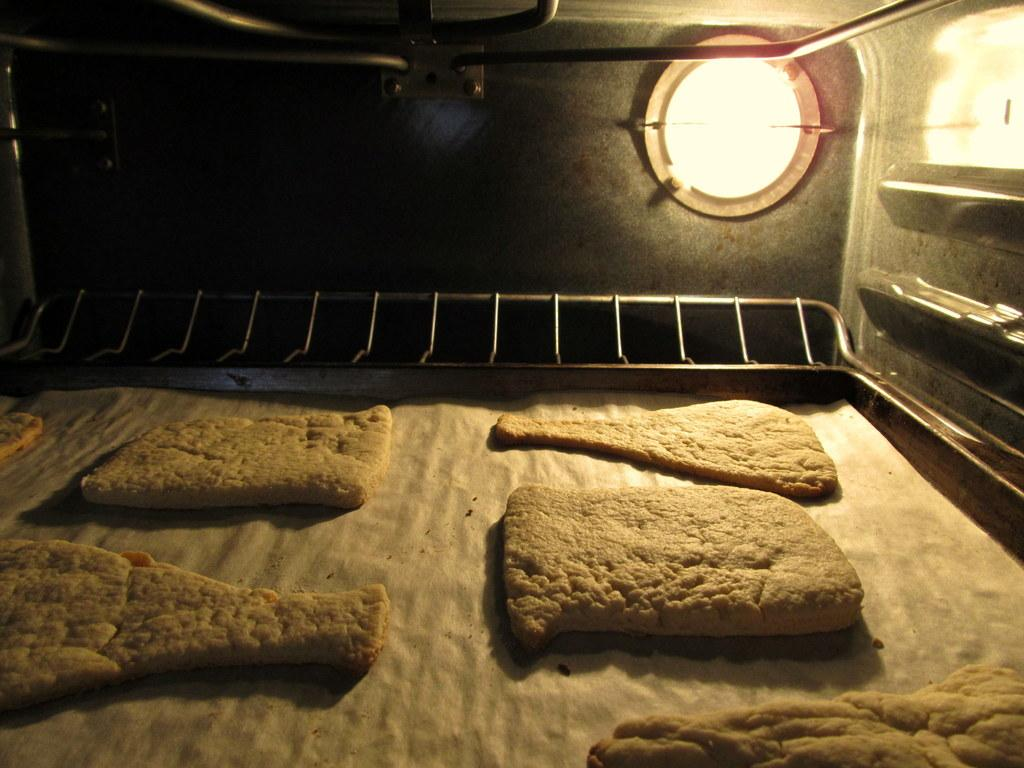What object is present in the image that might be used for holding or serving items? There is a tray in the image that can be used for holding or serving items. What is covering the tray in the image? The tray has a white cloth on it. What type of food can be seen on the tray? There are cookies on the tray. What can be seen providing illumination in the image? There is a light visible in the image. What type of stick is being used to transport the cookies in the image? There is no stick visible in the image, and the cookies are already on the tray. 